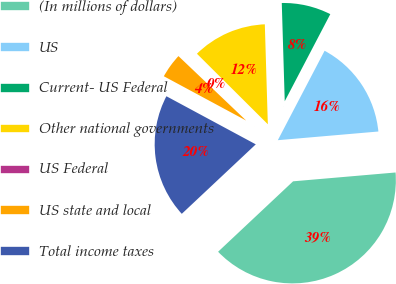Convert chart to OTSL. <chart><loc_0><loc_0><loc_500><loc_500><pie_chart><fcel>(In millions of dollars)<fcel>US<fcel>Current- US Federal<fcel>Other national governments<fcel>US Federal<fcel>US state and local<fcel>Total income taxes<nl><fcel>39.37%<fcel>15.96%<fcel>8.15%<fcel>12.06%<fcel>0.35%<fcel>4.25%<fcel>19.86%<nl></chart> 